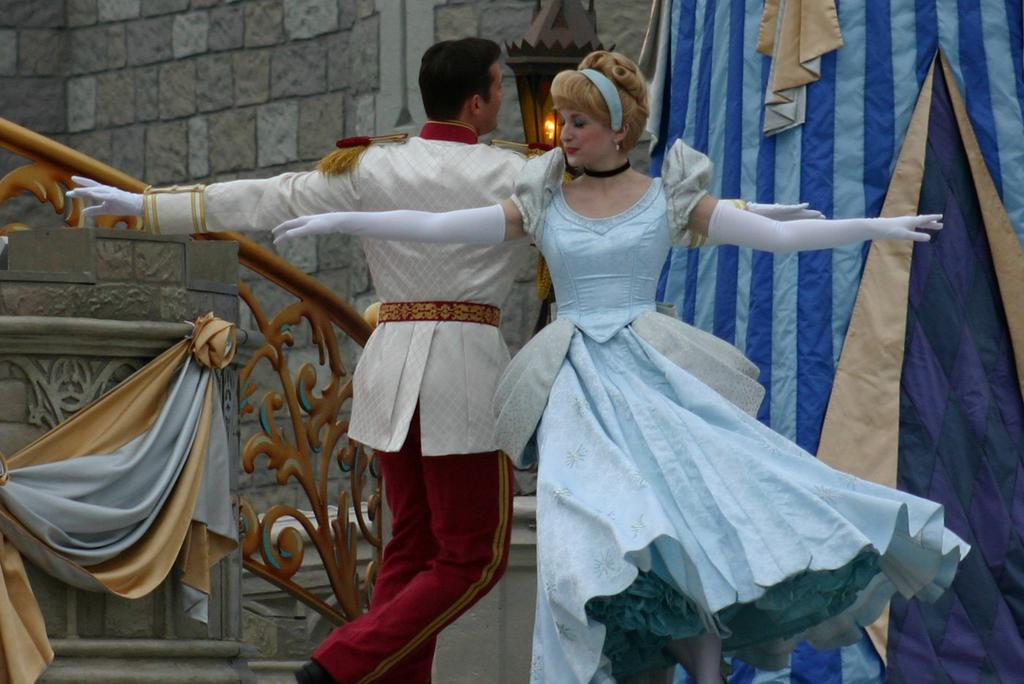What are the two people in the image doing? There is a couple dancing in the image. What can be seen in the background of the image? There is a tent in the background of the image. What architectural feature is visible in the image? There are stairs of a building in the image. What is located beside the text in the image? There is a lamp beside the text in the image. What type of cup is the lawyer holding in the image? There is no cup or lawyer present in the image; it features a couple dancing with a tent, stairs, and a lamp in the background. 